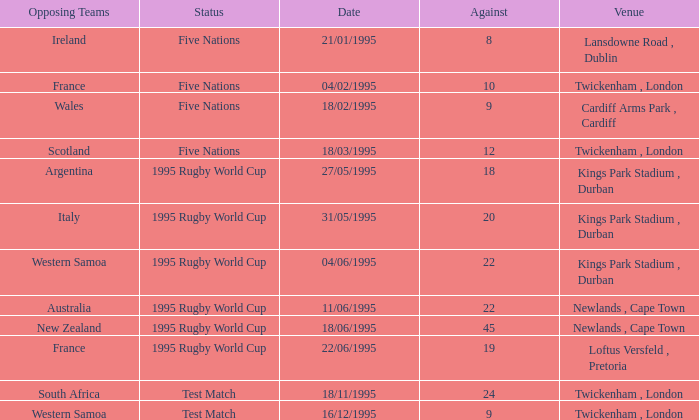What's the status with an against over 20 on 18/11/1995? Test Match. 